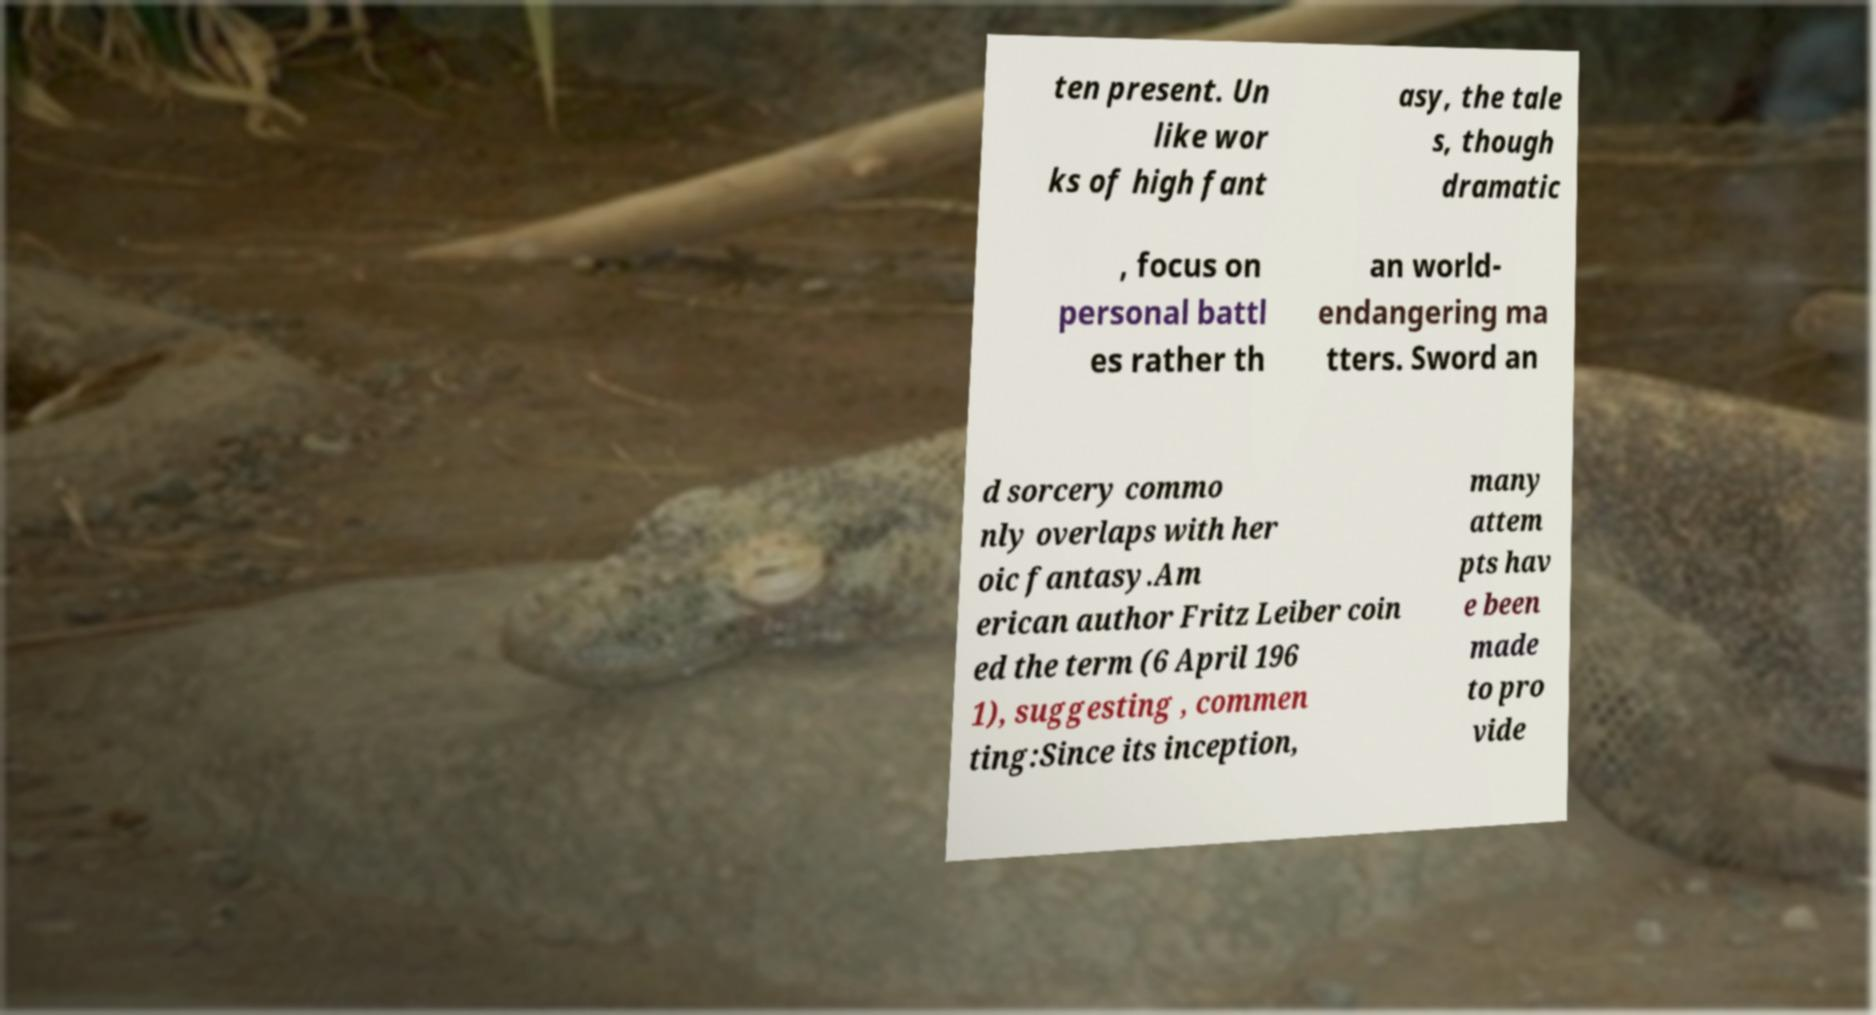Could you assist in decoding the text presented in this image and type it out clearly? ten present. Un like wor ks of high fant asy, the tale s, though dramatic , focus on personal battl es rather th an world- endangering ma tters. Sword an d sorcery commo nly overlaps with her oic fantasy.Am erican author Fritz Leiber coin ed the term (6 April 196 1), suggesting , commen ting:Since its inception, many attem pts hav e been made to pro vide 